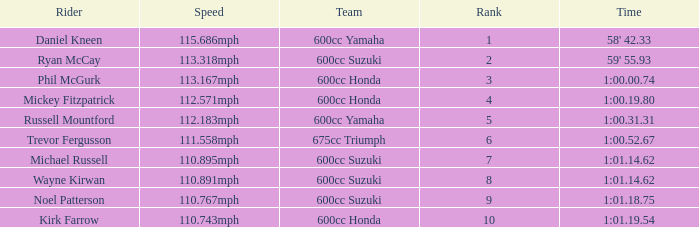How many ranks have 1:01.14.62 as the time, with michael russell as the rider? 1.0. 